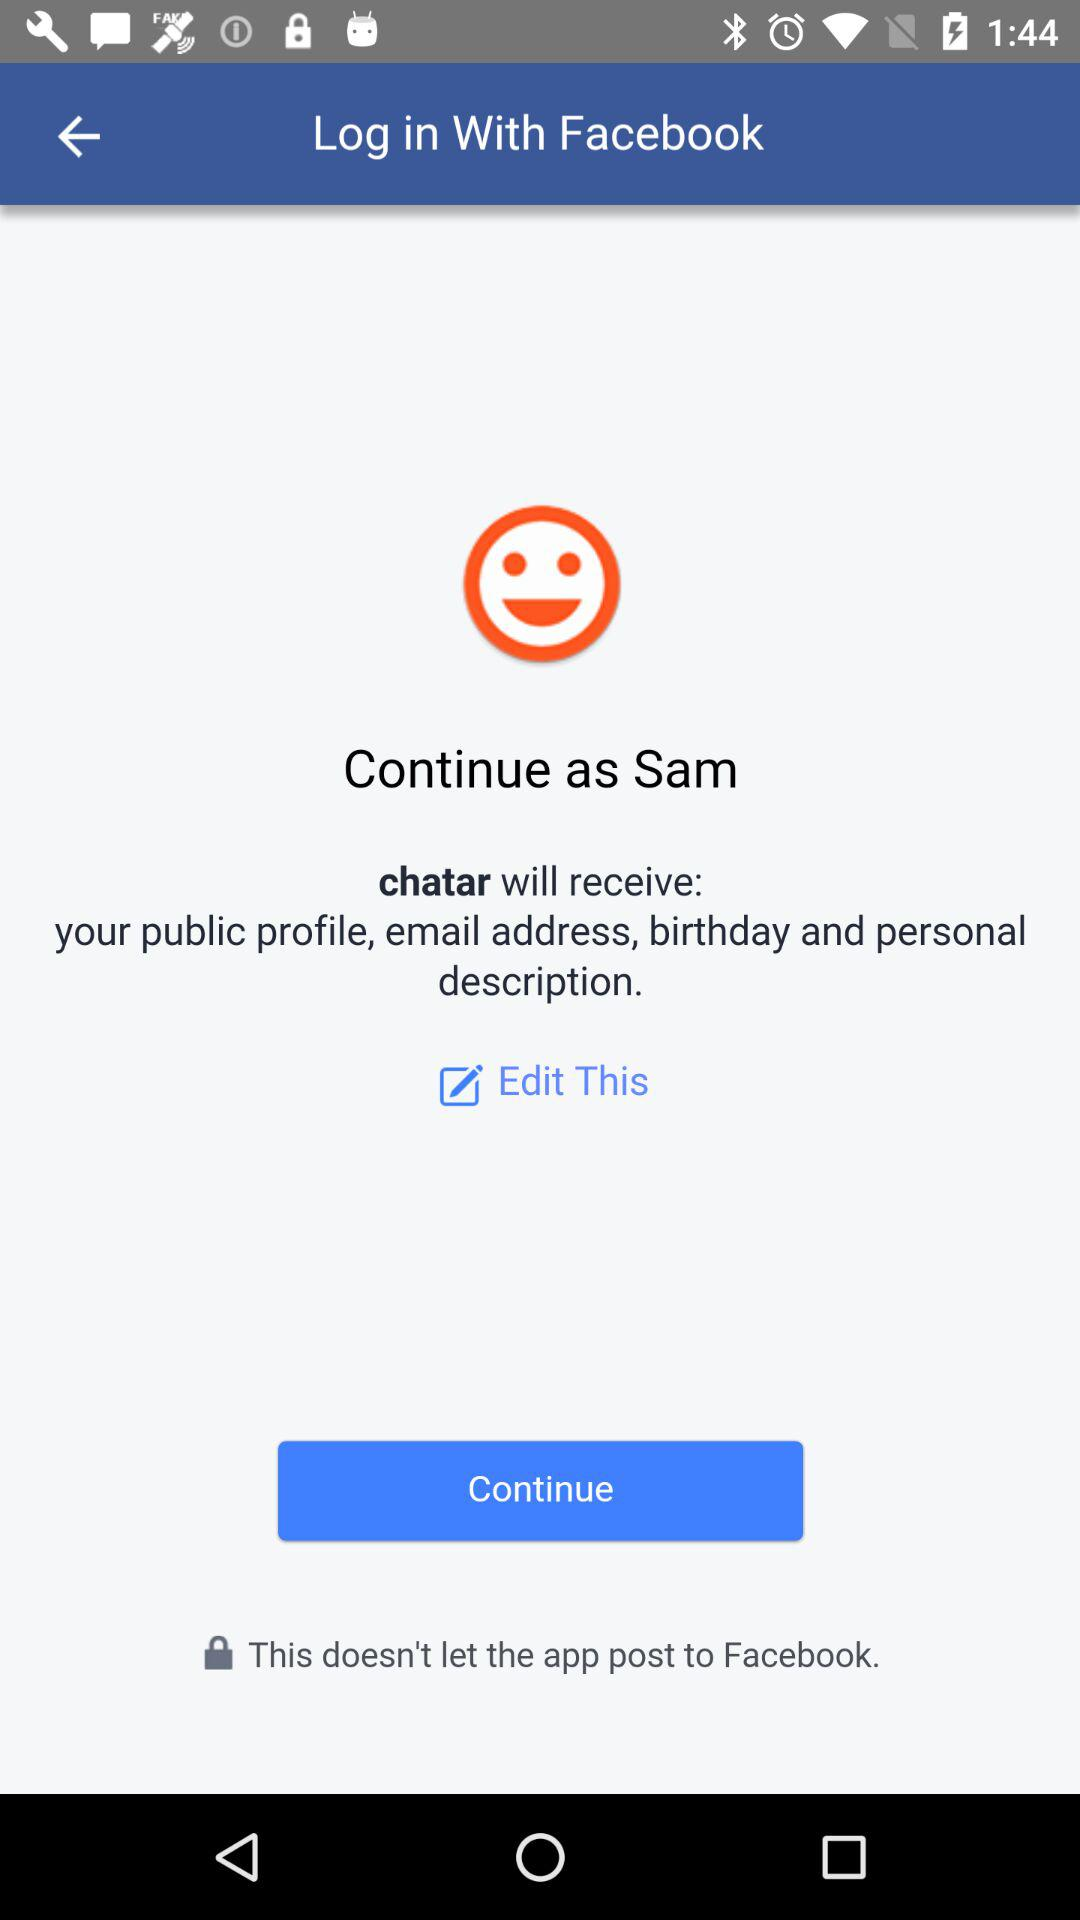How many items does the app receive from Facebook?
Answer the question using a single word or phrase. 4 